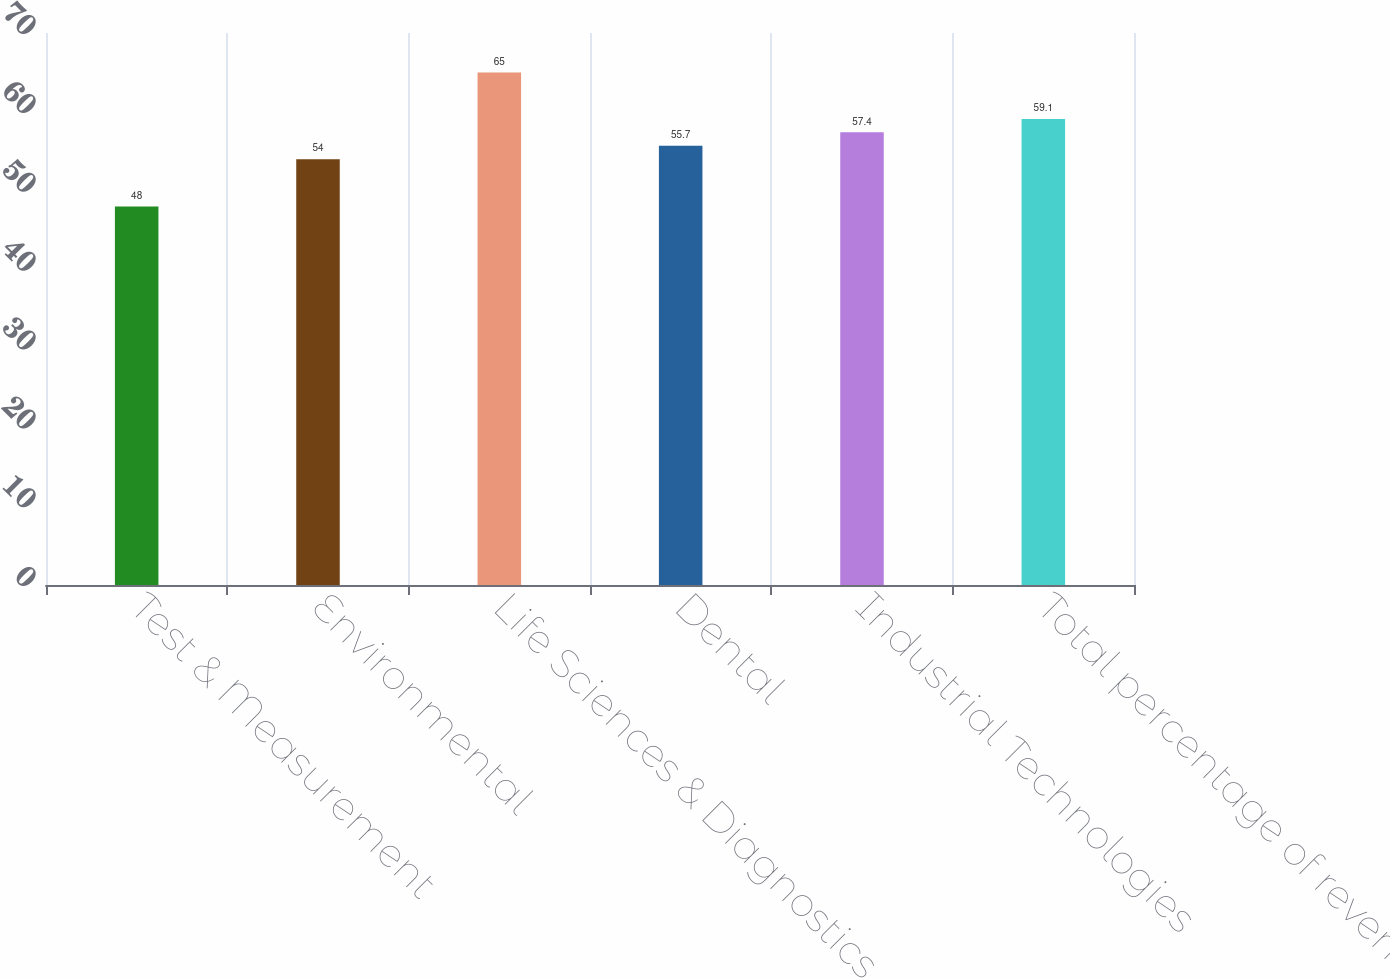<chart> <loc_0><loc_0><loc_500><loc_500><bar_chart><fcel>Test & Measurement<fcel>Environmental<fcel>Life Sciences & Diagnostics<fcel>Dental<fcel>Industrial Technologies<fcel>Total percentage of revenue<nl><fcel>48<fcel>54<fcel>65<fcel>55.7<fcel>57.4<fcel>59.1<nl></chart> 